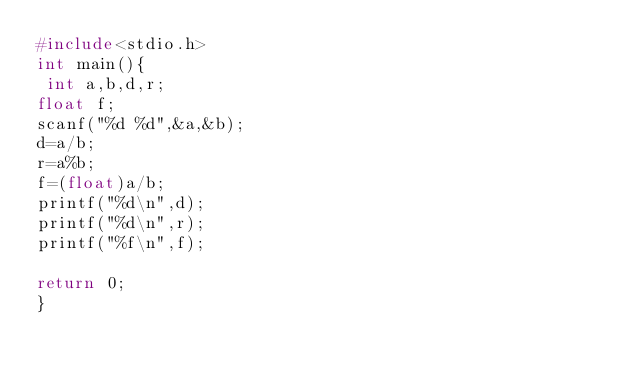<code> <loc_0><loc_0><loc_500><loc_500><_C_>#include<stdio.h>
int main(){
 int a,b,d,r;
float f;
scanf("%d %d",&a,&b);
d=a/b;
r=a%b;
f=(float)a/b;
printf("%d\n",d);
printf("%d\n",r);
printf("%f\n",f);

return 0;
}</code> 